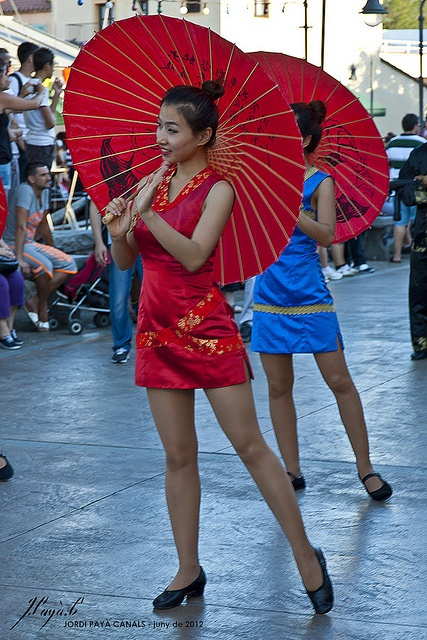Describe the objects in this image and their specific colors. I can see umbrella in tan, brown, maroon, and black tones, people in tan, gray, brown, maroon, and black tones, people in tan, gray, blue, and black tones, umbrella in tan, brown, and maroon tones, and people in tan, black, and gray tones in this image. 